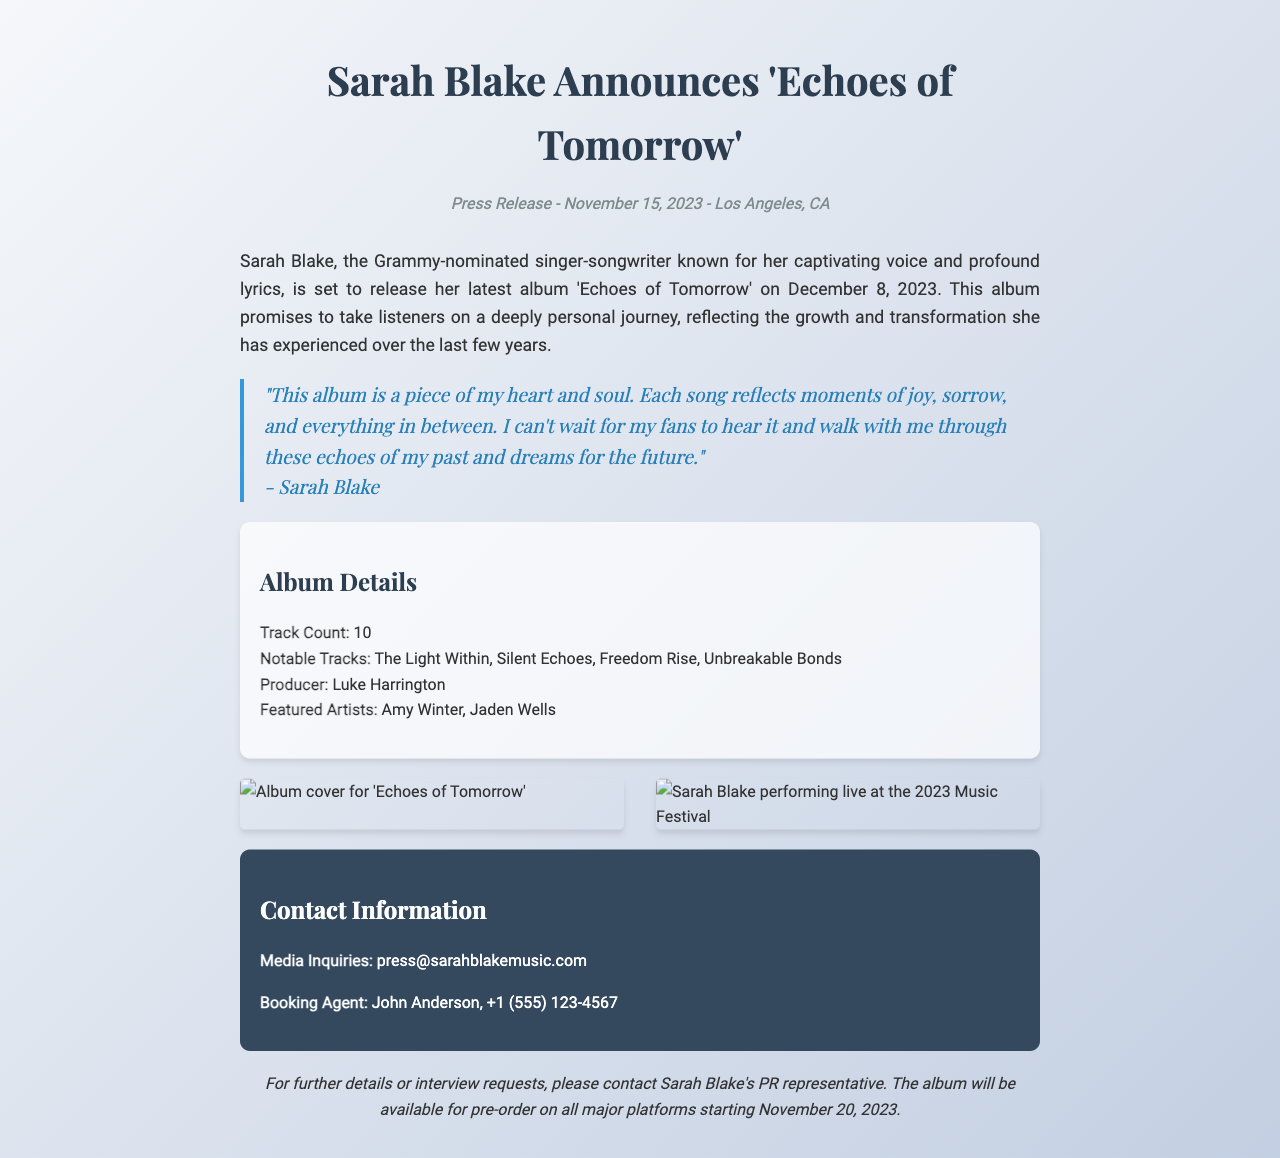What is the album title? The album title is explicitly stated in the document as 'Echoes of Tomorrow'.
Answer: Echoes of Tomorrow When is the album release date? The release date is mentioned in the press release as December 8, 2023.
Answer: December 8, 2023 Who is the producer of the album? The producer's name is listed clearly in the album details section as Luke Harrington.
Answer: Luke Harrington How many tracks are on the album? The track count is specified as 10 in the album details section.
Answer: 10 What is the notable track that reflects themes of freedom? The notable track that relates to freedom is mentioned as 'Freedom Rise' in the list of notable tracks.
Answer: Freedom Rise What sentiment does Sarah Blake express about her album? Sarah Blake describes her album as a piece of her heart and soul in the quote provided.
Answer: Piece of my heart and soul What date will the album be available for pre-order? The pre-order date is indicated as November 20, 2023.
Answer: November 20, 2023 Which two artists are featured on the album? The featured artists are explicitly mentioned as Amy Winter and Jaden Wells in the document.
Answer: Amy Winter, Jaden Wells What type of document is this? This document is a press release for an album launch, as indicated in the title and structure.
Answer: Press release 